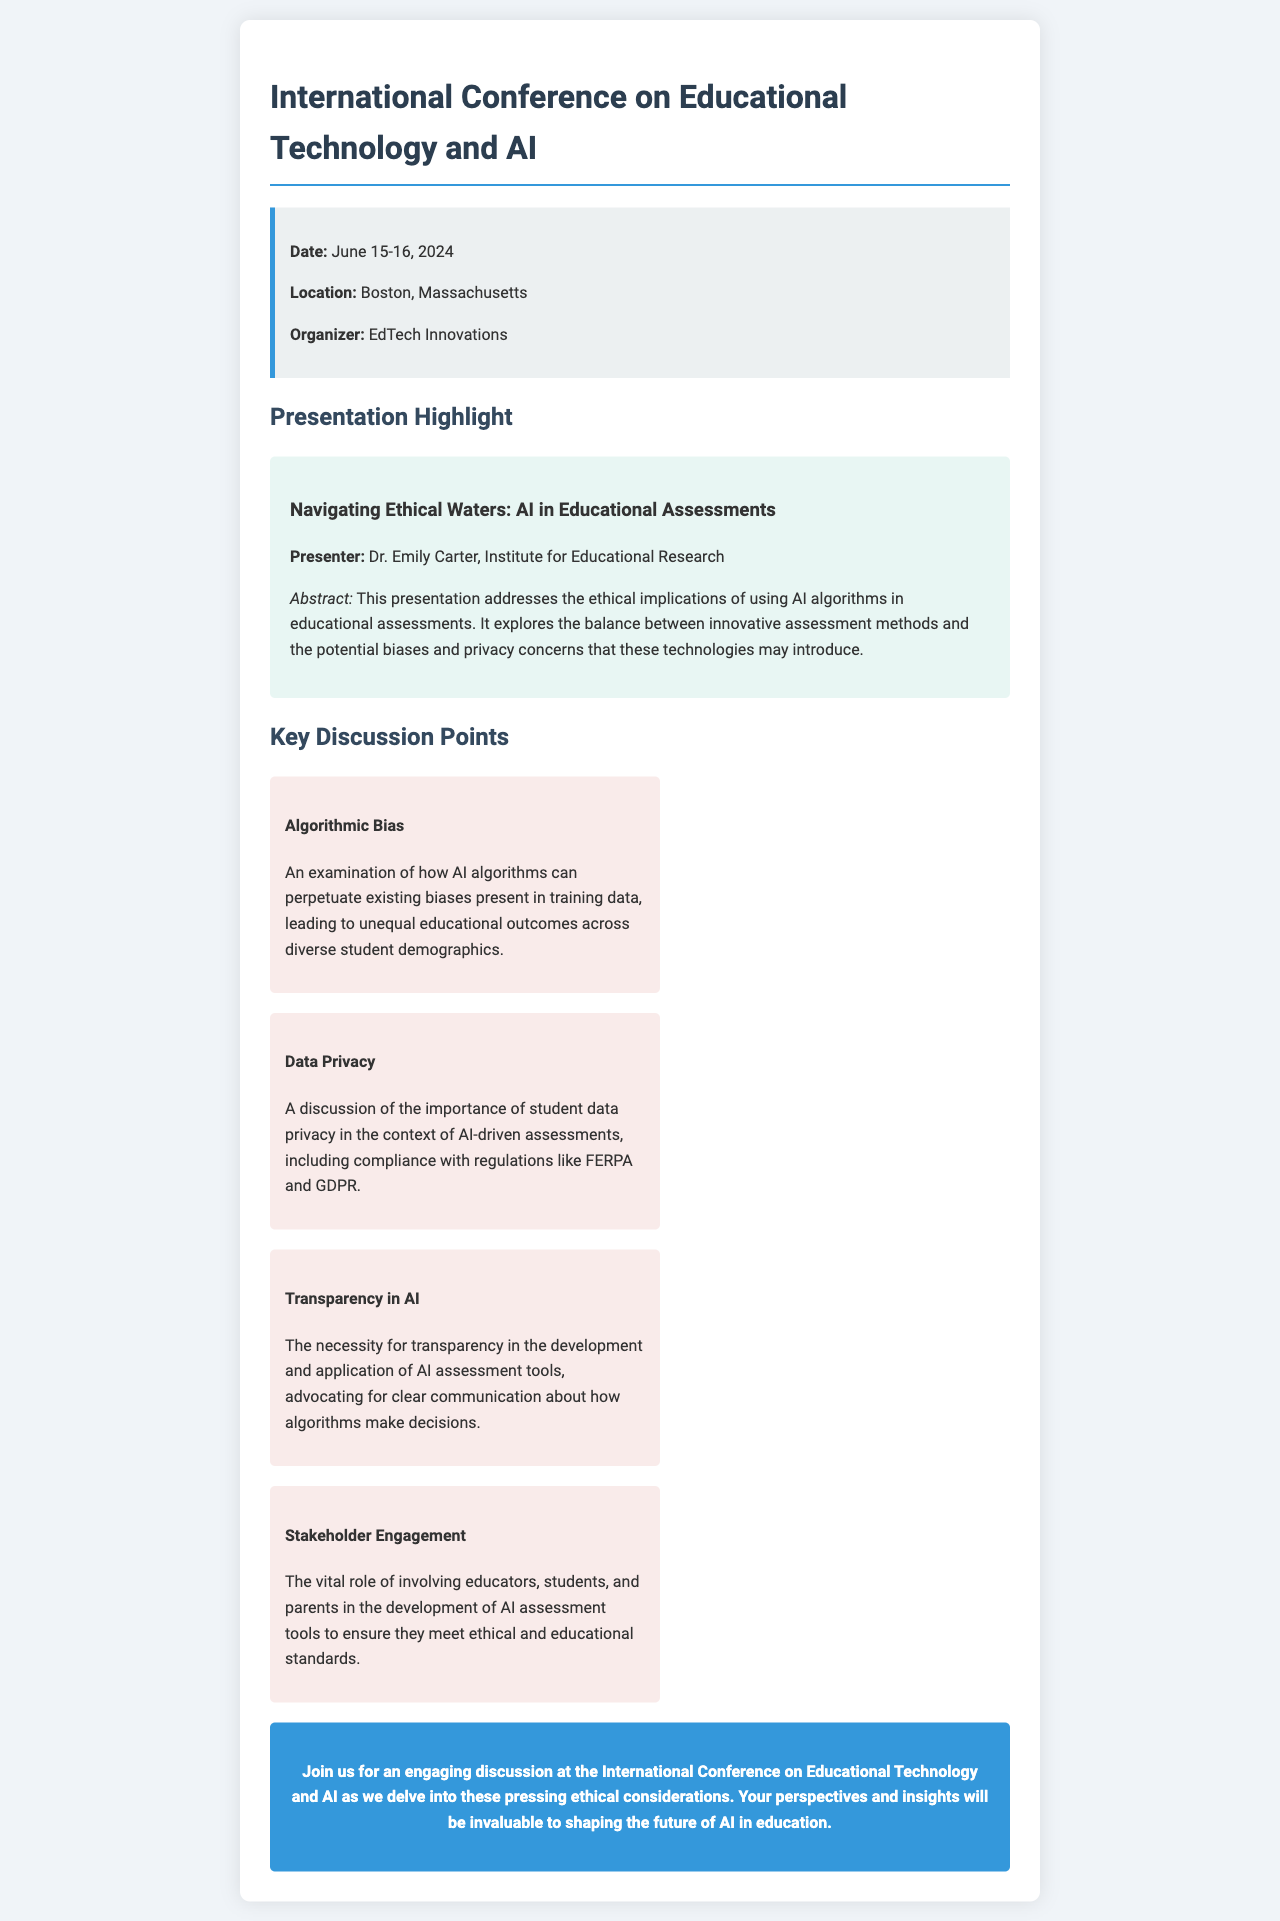What is the date of the conference? The date is explicitly mentioned in the document as June 15-16, 2024.
Answer: June 15-16, 2024 Who is the presenter of the highlighted presentation? The document provides the name of the presenter, Dr. Emily Carter, under the presentation summary section.
Answer: Dr. Emily Carter What is the main focus of Dr. Emily Carter's presentation? The abstract mentions the focus on ethical implications of using AI algorithms in educational assessments.
Answer: Ethical implications of using AI algorithms What is one key discussion point about AI in educational assessments? The document lists four key discussion points, one of which is algorithmic bias.
Answer: Algorithmic bias What organization is hosting the conference? The organizer of the conference is clearly stated in the conference details section of the document.
Answer: EdTech Innovations What is the role of stakeholder engagement mentioned in the document? Stakeholder engagement is discussed as essential in involving educators, students, and parents in the development of AI assessment tools.
Answer: Involving educators, students, and parents What color is used for the call-to-action section? The document describes the call-to-action section as having a background color of #3498db, a shade of blue.
Answer: Blue How is data privacy addressed in the presentation theme? The document specifically talks about the importance of student data privacy in AI-driven assessments.
Answer: Importance of student data privacy What type of document is this? This document serves as an invitation to a conference, summarizing a presentation and key discussion points.
Answer: Invitation letter 